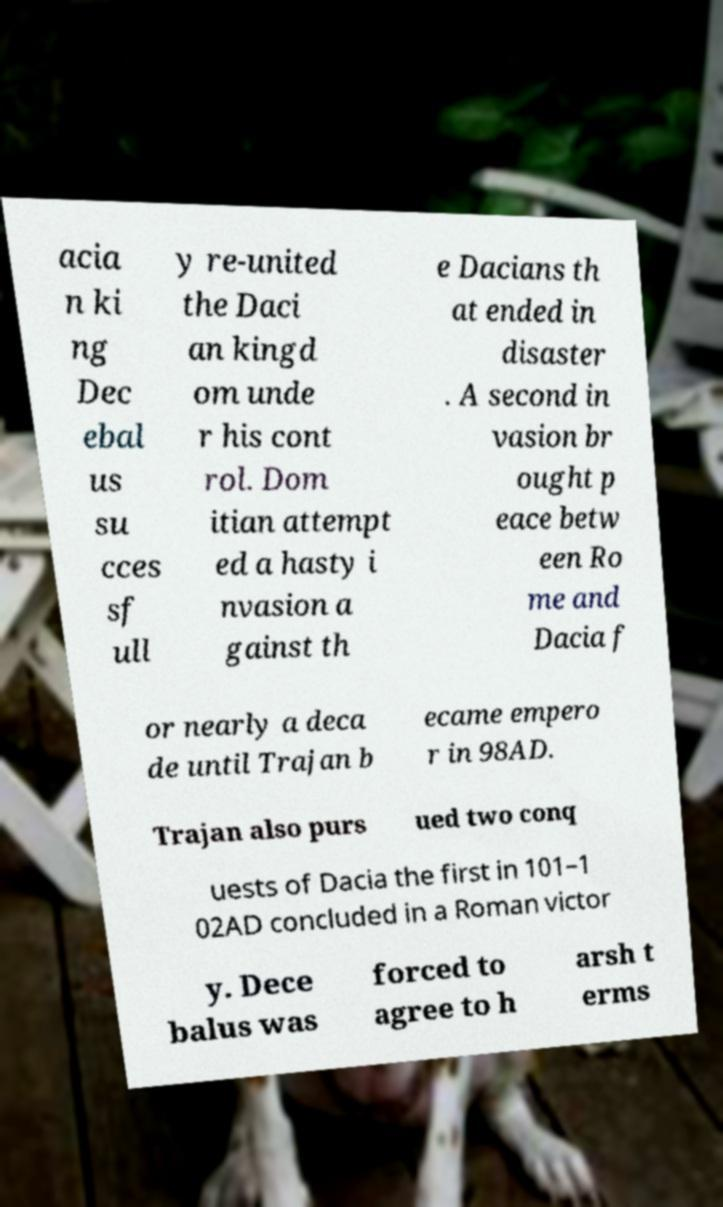I need the written content from this picture converted into text. Can you do that? acia n ki ng Dec ebal us su cces sf ull y re-united the Daci an kingd om unde r his cont rol. Dom itian attempt ed a hasty i nvasion a gainst th e Dacians th at ended in disaster . A second in vasion br ought p eace betw een Ro me and Dacia f or nearly a deca de until Trajan b ecame empero r in 98AD. Trajan also purs ued two conq uests of Dacia the first in 101–1 02AD concluded in a Roman victor y. Dece balus was forced to agree to h arsh t erms 